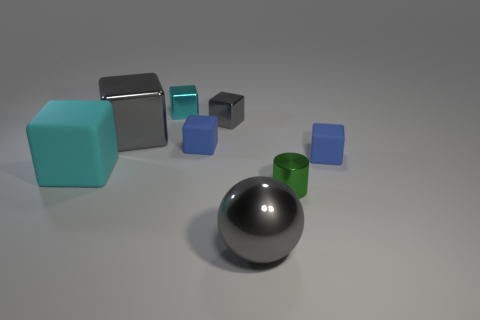Is the color of the large thing in front of the cylinder the same as the big shiny block?
Your answer should be compact. Yes. There is a tiny cube that is the same color as the big metallic block; what is its material?
Your response must be concise. Metal. How many cyan objects are either tiny cylinders or tiny blocks?
Offer a terse response. 1. Is the shape of the large shiny object to the left of the tiny gray metal object the same as the gray object that is in front of the large gray shiny cube?
Keep it short and to the point. No. What number of other things are there of the same material as the small gray thing
Provide a succinct answer. 4. Are there any shiny balls that are on the left side of the big gray object that is right of the tiny blue matte block that is left of the gray sphere?
Offer a terse response. No. Do the small cyan thing and the gray ball have the same material?
Your answer should be compact. Yes. Is there anything else that has the same shape as the big cyan object?
Ensure brevity in your answer.  Yes. What material is the large thing on the right side of the blue rubber object that is left of the metal cylinder?
Provide a short and direct response. Metal. What size is the gray object on the left side of the small cyan cube?
Provide a succinct answer. Large. 